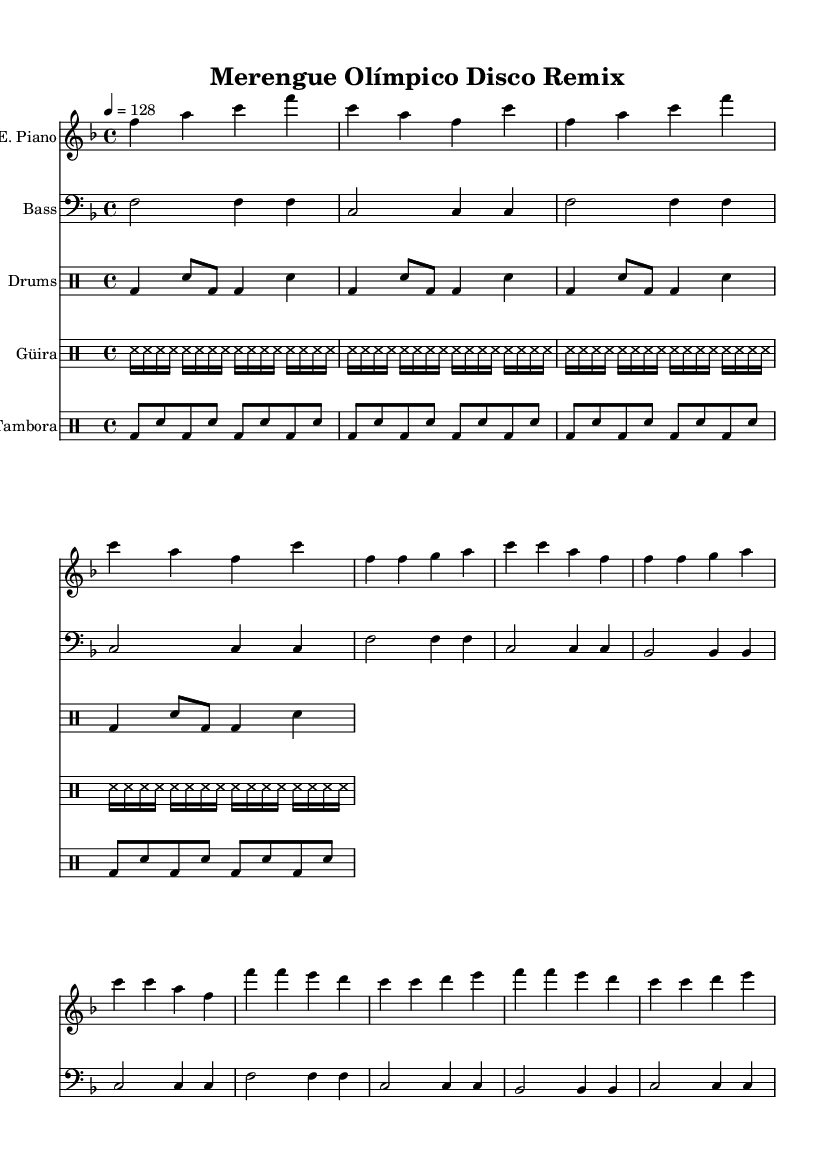What is the key signature of this music? The key signature is F major, which contains one flat (B flat). This can be determined by locating the key signature section at the beginning of the staff, which shows one flat symbol.
Answer: F major What is the time signature of the piece? The time signature is 4/4, indicated at the beginning of the score. This means there are four beats per measure, and the quarter note receives one beat.
Answer: 4/4 What is the tempo marking for this piece? The tempo marking is 128 beats per minute, as specified in the score with "4 = 128" under the tempo indication. This shows how fast the piece should be played.
Answer: 128 How many measures are in the intro section? The intro consists of 4 measures, which can be identified by counting the grouped musical segments before the verse starts; each segment represents a measure.
Answer: 4 What instruments are included in this arrangement? The score includes electric piano, bass guitar, drums, güira, and tambora, as indicated by the instrument names at the start of each staff. Each staff is labeled with the corresponding instrument.
Answer: Electric Piano, Bass, Drums, Güira, Tambora What rhythmic pattern is primarily used in the drum section? The primary drum pattern consists of bass drum and snare combinations, as indicated in the drum notations. Specifically, there are repeated sequences of bass drum (bd) and snare (sn) notes throughout the score.
Answer: Bass and snare combination What is the predominant musical genre of this piece? The predominant genre is disco, as indicated in the title "Merengue Olímpico Disco Remix." This reflects a mix of traditional merengue with the disco style, aimed at high-energy dance.
Answer: Disco 